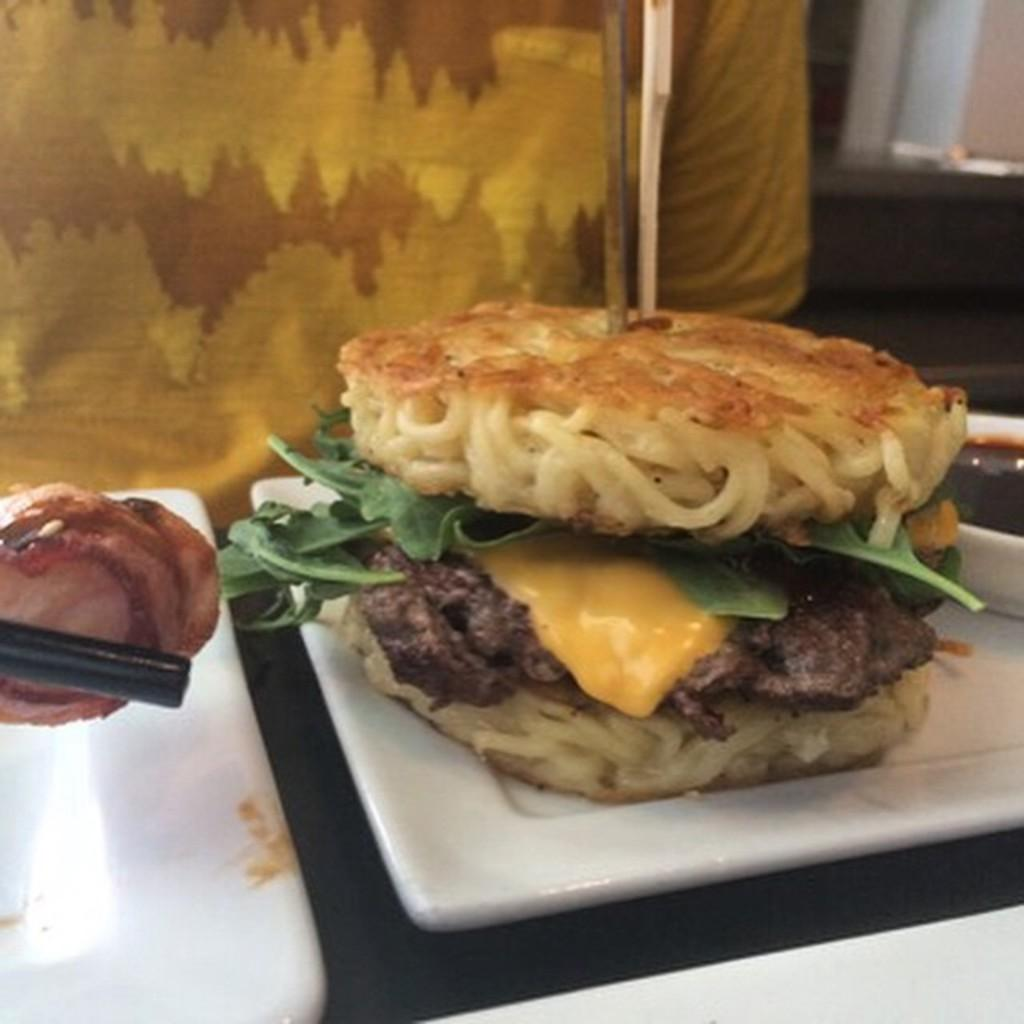What type of items can be seen in the image? There are good items in the image. What objects are used for holding or serving food in the image? There are sticks and trays in the image. What is in the bowl that is visible in the image? There is a bowl of sauce in the image. Can you describe the presence of a person in the image? There is a person in the background of the image. What type of vegetable is being used as a seat in the image? There is no vegetable being used as a seat in the image. What type of food is the person in the background eating? The provided facts do not mention any food being eaten by the person in the background, so it cannot be determined from the image. 